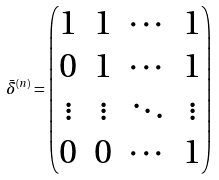Convert formula to latex. <formula><loc_0><loc_0><loc_500><loc_500>\bar { \delta } ^ { ( n ) } = \begin{pmatrix} 1 & 1 & \cdots & 1 \\ 0 & 1 & \cdots & 1 \\ \vdots & \vdots & \ddots & \vdots \\ 0 & 0 & \cdots & 1 \end{pmatrix}</formula> 